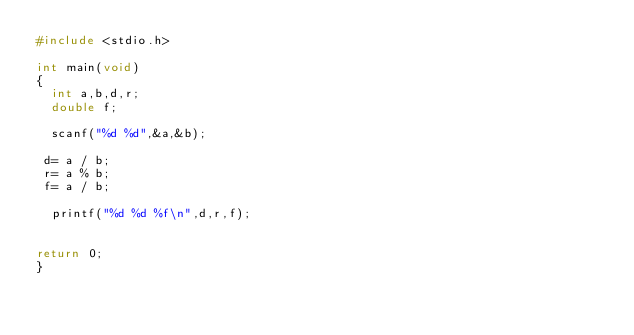<code> <loc_0><loc_0><loc_500><loc_500><_C_>#include <stdio.h>

int main(void)
{
  int a,b,d,r;
  double f;

  scanf("%d %d",&a,&b);

 d= a / b;
 r= a % b;
 f= a / b;

  printf("%d %d %f\n",d,r,f);
           

return 0;
}
</code> 